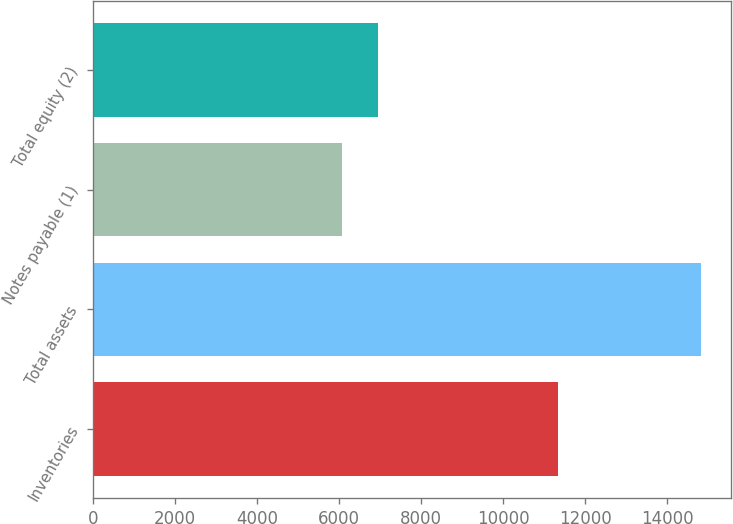Convert chart to OTSL. <chart><loc_0><loc_0><loc_500><loc_500><bar_chart><fcel>Inventories<fcel>Total assets<fcel>Notes payable (1)<fcel>Total equity (2)<nl><fcel>11343.1<fcel>14820.7<fcel>6078.6<fcel>6952.81<nl></chart> 